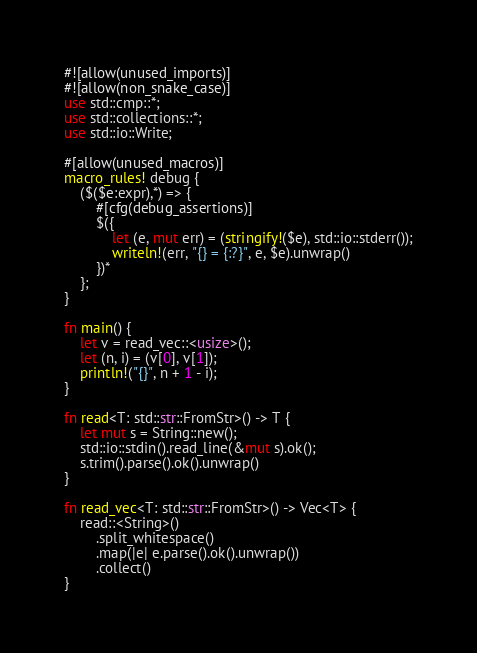<code> <loc_0><loc_0><loc_500><loc_500><_Rust_>#![allow(unused_imports)]
#![allow(non_snake_case)]
use std::cmp::*;
use std::collections::*;
use std::io::Write;

#[allow(unused_macros)]
macro_rules! debug {
    ($($e:expr),*) => {
        #[cfg(debug_assertions)]
        $({
            let (e, mut err) = (stringify!($e), std::io::stderr());
            writeln!(err, "{} = {:?}", e, $e).unwrap()
        })*
    };
}

fn main() {
    let v = read_vec::<usize>();
    let (n, i) = (v[0], v[1]);
    println!("{}", n + 1 - i);
}

fn read<T: std::str::FromStr>() -> T {
    let mut s = String::new();
    std::io::stdin().read_line(&mut s).ok();
    s.trim().parse().ok().unwrap()
}

fn read_vec<T: std::str::FromStr>() -> Vec<T> {
    read::<String>()
        .split_whitespace()
        .map(|e| e.parse().ok().unwrap())
        .collect()
}
</code> 